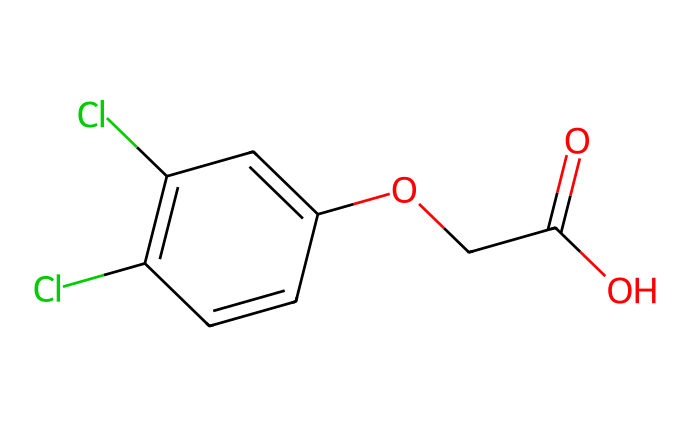What is the chemical name of this compound? The SMILES representation provided corresponds to 2,4-Dichlorophenoxyacetic acid, which is commonly used as a herbicide.
Answer: 2,4-Dichlorophenoxyacetic acid How many carbon atoms are in the structure? By analyzing the SMILES representation, we can count the occurrences of carbon (C) atoms within the structure. There are 10 carbon atoms in the structure of 2,4-Dichlorophenoxyacetic acid.
Answer: 10 What functional groups are present in this molecule? The functional groups can be identified by finding distinct structural features within the molecule. This structure includes a carboxylic acid group (-COOH) and an ether group (-O-).
Answer: carboxylic acid and ether How many chlorine atoms are present in the chemical? The SMILES representation shows two occurrences of chlorine (Cl) connected to the aromatic ring, indicating that there are two chlorine atoms in the molecule.
Answer: 2 What is the molecular weight of 2,4-Dichlorophenoxyacetic acid? The molecular weight can be calculated by adding the atomic weights of each atom present based on the molecular formula derived from the SMILES representation. The molecular weight of 2,4-D is approximately 221.05 g/mol.
Answer: 221.05 How does the presence of chlorine influence the herbicidal properties of this compound? Chlorine atoms in the molecule contribute to its reactivity and stability, enhancing its effectiveness as a herbicide. They help in disrupting plant growth by influencing hormone pathways.
Answer: enhances effectiveness Which aspect of this chemical structure allows it to inhibit growth in plants? The presence of the phenoxy group in the structure interacts with plant growth regulators, mimicking auxins, which leads to uncontrolled growth and eventual death of weeds.
Answer: phenoxy group 